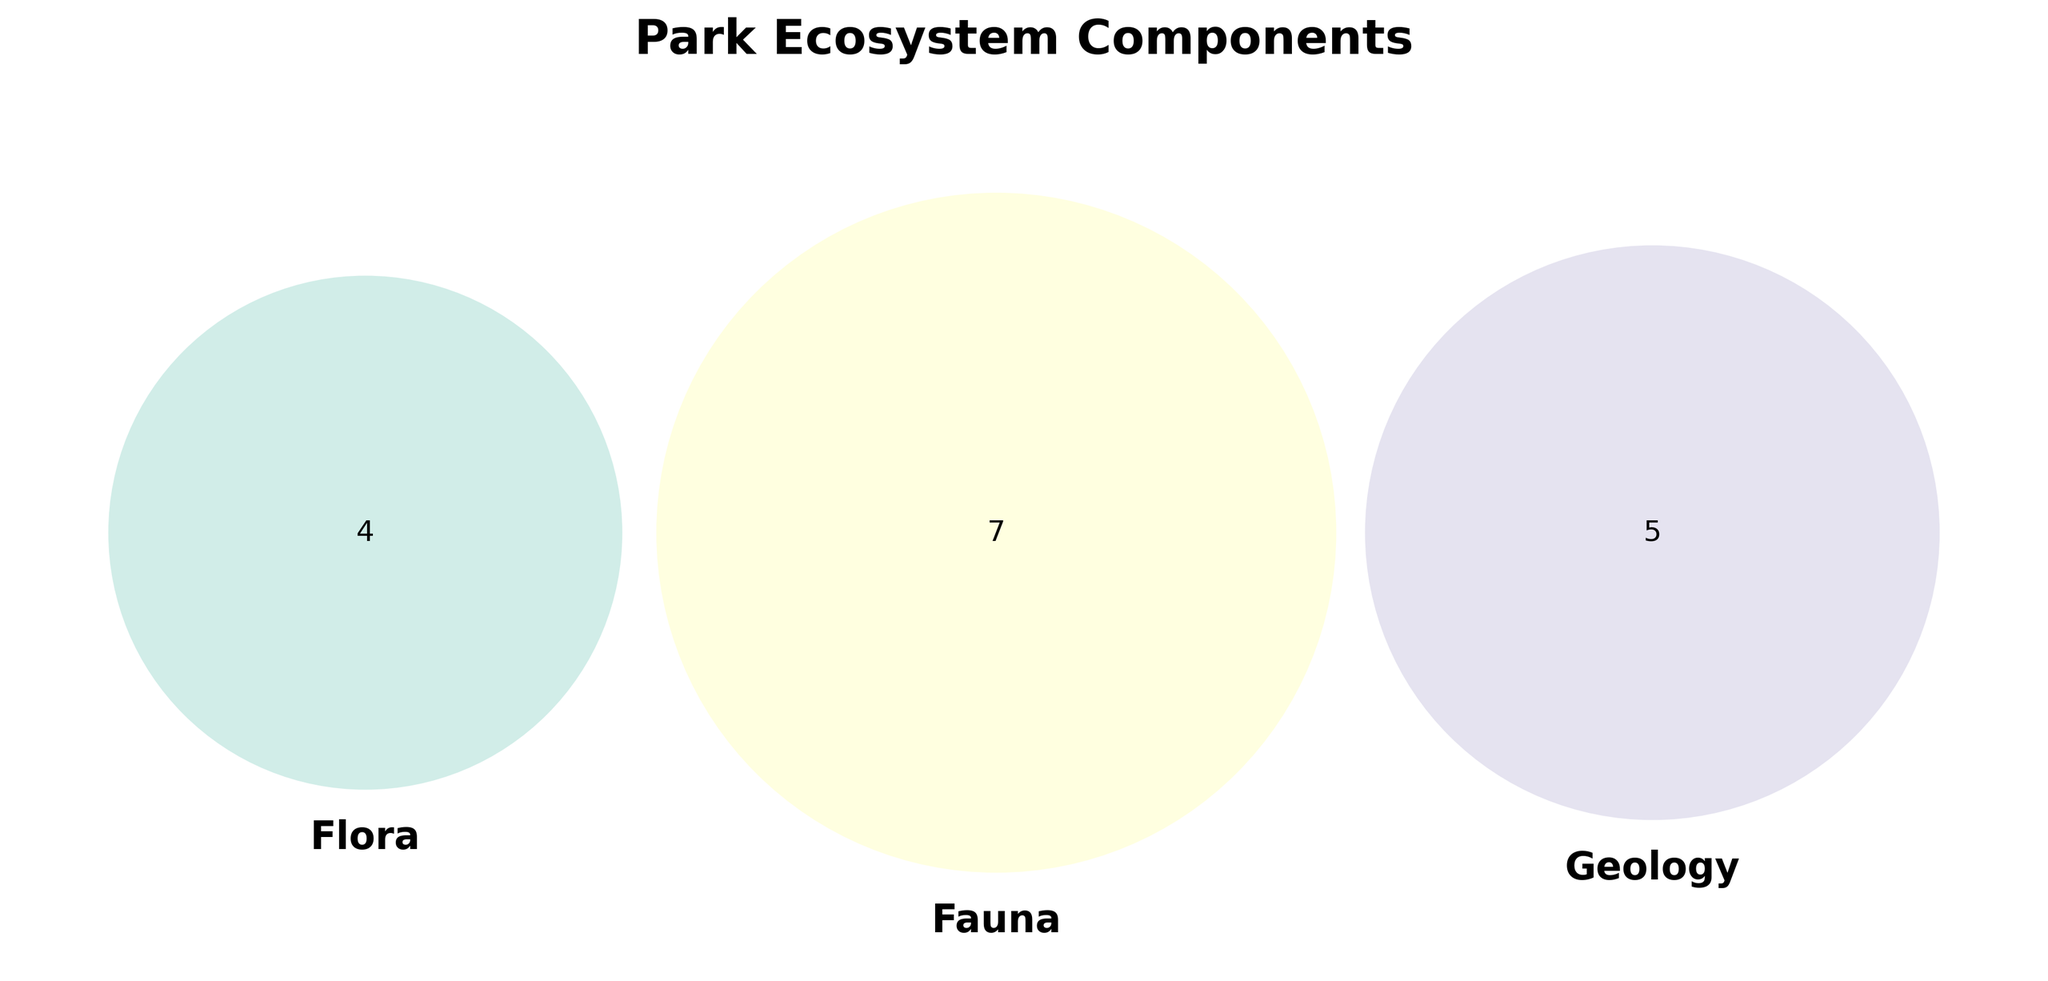What is the title of the Venn diagram? The title is positioned at the top of the figure in bold and large font. It summarizes the content of the diagram.
Answer: Park Ecosystem Components How many unique elements are only in the Fauna category? Look at the section of the Venn diagram that corresponds to the Fauna category, excluding the overlaps with other categories. Count the unique elements within this section.
Answer: 4 Which types of fauna also share a habitat with geological features? Identify the overlapping section between the Fauna category and the Geology category. Check the elements that appear within this overlap.
Answer: Golden eagles What is the intersection between Flora, Fauna, and Geology? Locate the central area where all three circles (Flora, Fauna, and Geology) intersect. Identify the elements that fall within this intersection.
Answer: (None) How many types of flora are there in total? Count all unique elements in the Flora category. Include those that may overlap with Fauna and/or Geology categories.
Answer: 4 Which category has the smallest intersection with Flora? Compare the overlapping sections between Flora and the other two categories (Fauna, Geology). Identify the intersection with the smallest number of elements.
Answer: Geology How many unique types of geological features are there? Count all unique elements in the Geology category. Include those that may overlap with Flora and/or Fauna categories.
Answer: 5 